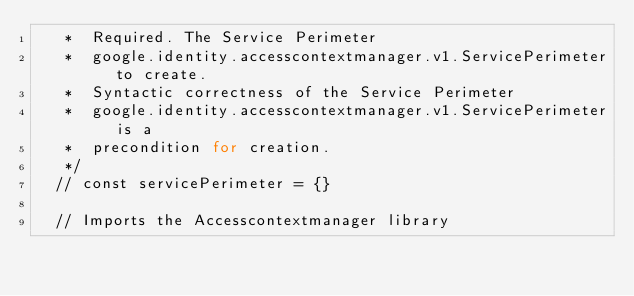Convert code to text. <code><loc_0><loc_0><loc_500><loc_500><_JavaScript_>   *  Required. The Service Perimeter 
   *  google.identity.accesscontextmanager.v1.ServicePerimeter  to create.
   *  Syntactic correctness of the Service Perimeter 
   *  google.identity.accesscontextmanager.v1.ServicePerimeter  is a
   *  precondition for creation.
   */
  // const servicePerimeter = {}

  // Imports the Accesscontextmanager library</code> 